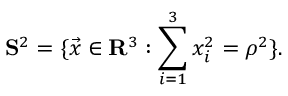<formula> <loc_0><loc_0><loc_500><loc_500>{ S } ^ { 2 } = \{ \vec { x } \in { R } ^ { 3 } \colon \sum _ { i = 1 } ^ { 3 } x _ { i } ^ { 2 } = { \rho } ^ { 2 } \} .</formula> 